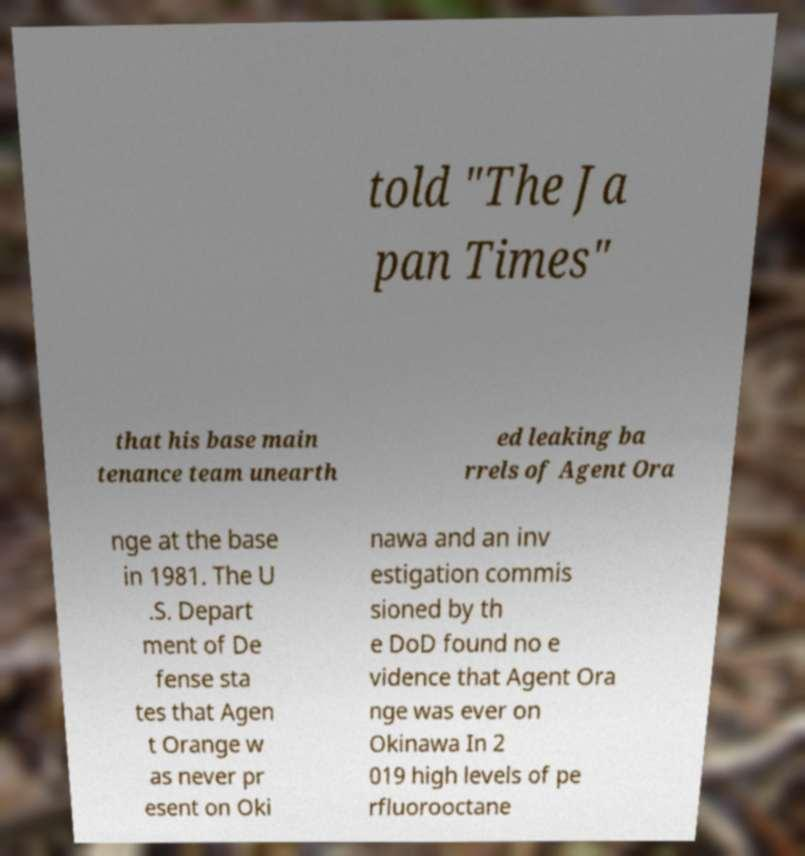Can you accurately transcribe the text from the provided image for me? told "The Ja pan Times" that his base main tenance team unearth ed leaking ba rrels of Agent Ora nge at the base in 1981. The U .S. Depart ment of De fense sta tes that Agen t Orange w as never pr esent on Oki nawa and an inv estigation commis sioned by th e DoD found no e vidence that Agent Ora nge was ever on Okinawa In 2 019 high levels of pe rfluorooctane 